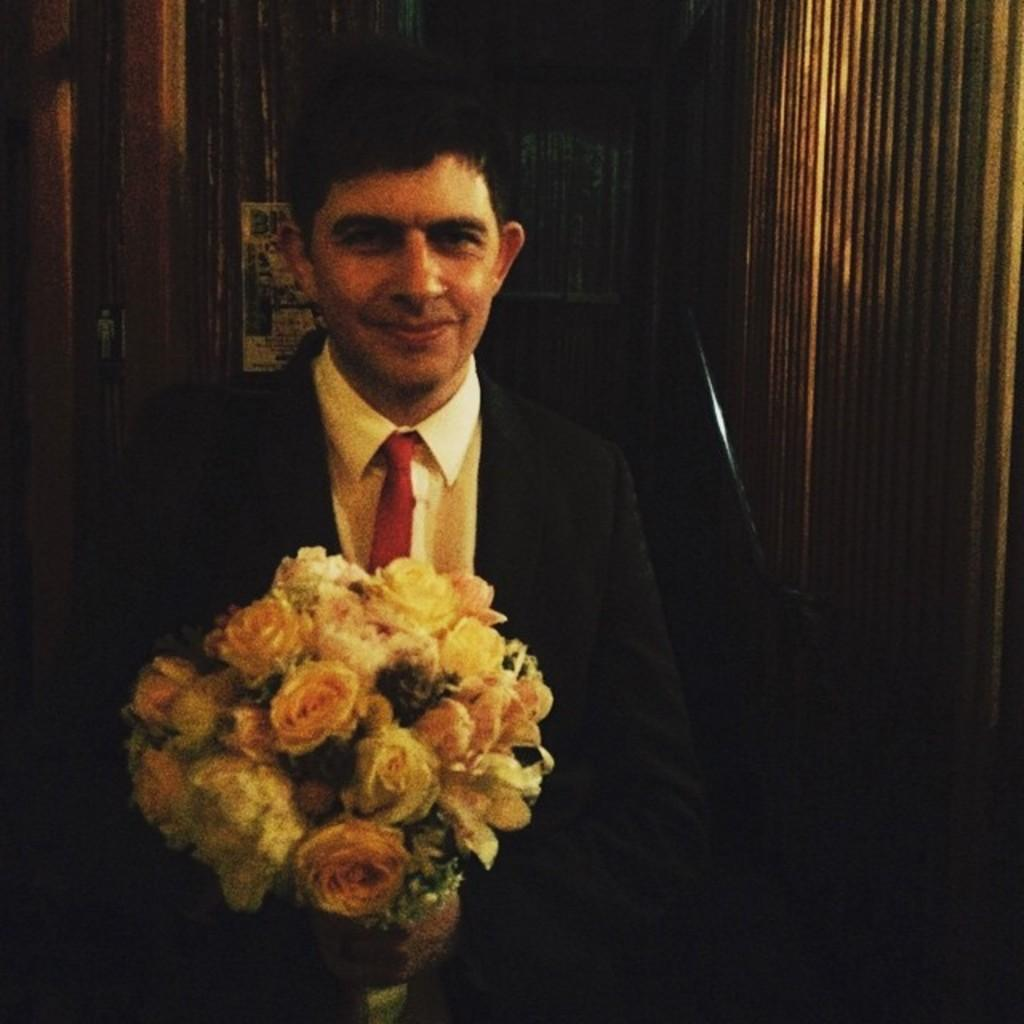What is the main subject of the image? There is a man in the image. What color is the coat the man is wearing? The man is wearing a black coat. What color is the shirt the man is wearing? The man is wearing a white shirt. What color is the tie the man is wearing? The man is wearing a red tie. What is the man holding in his hand? The man is holding a bouquet in his hand. How does the man force the dust to move in the image? There is no dust present in the image, and the man is not shown forcing anything to move. 